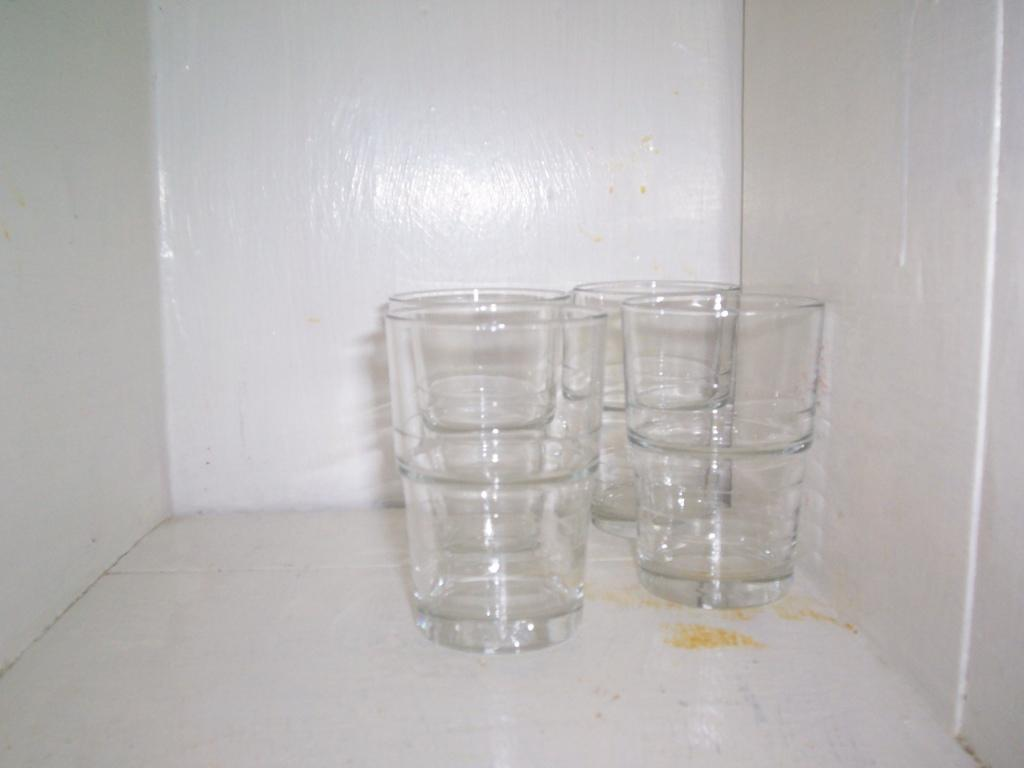What type of furniture is present in the image? There is a white-colored cabinet in the image. What items can be seen inside the cabinet? There are glasses in the cabinet. What type of gate is visible in the image? There is no gate present in the image; it only features a white-colored cabinet with glasses inside. Is there a bomb hidden behind the cabinet in the image? There is no bomb present in the image; it only features a white-colored cabinet with glasses inside. 